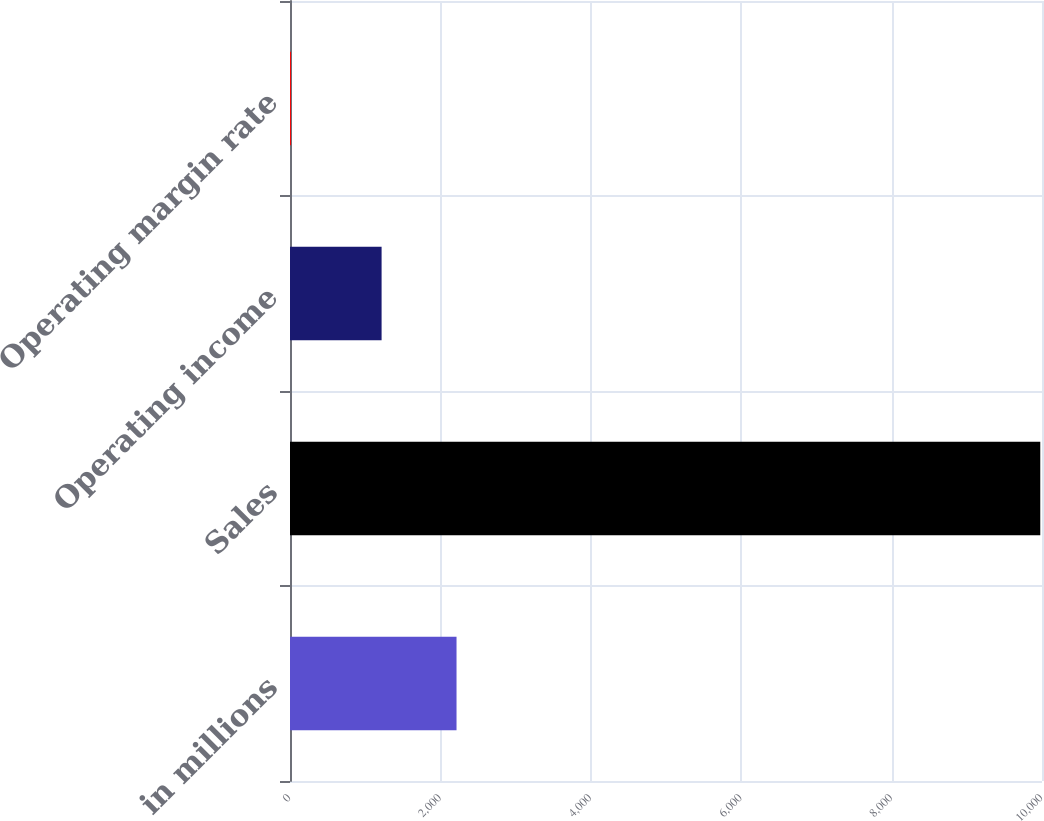Convert chart to OTSL. <chart><loc_0><loc_0><loc_500><loc_500><bar_chart><fcel>in millions<fcel>Sales<fcel>Operating income<fcel>Operating margin rate<nl><fcel>2214.48<fcel>9977<fcel>1218<fcel>12.2<nl></chart> 